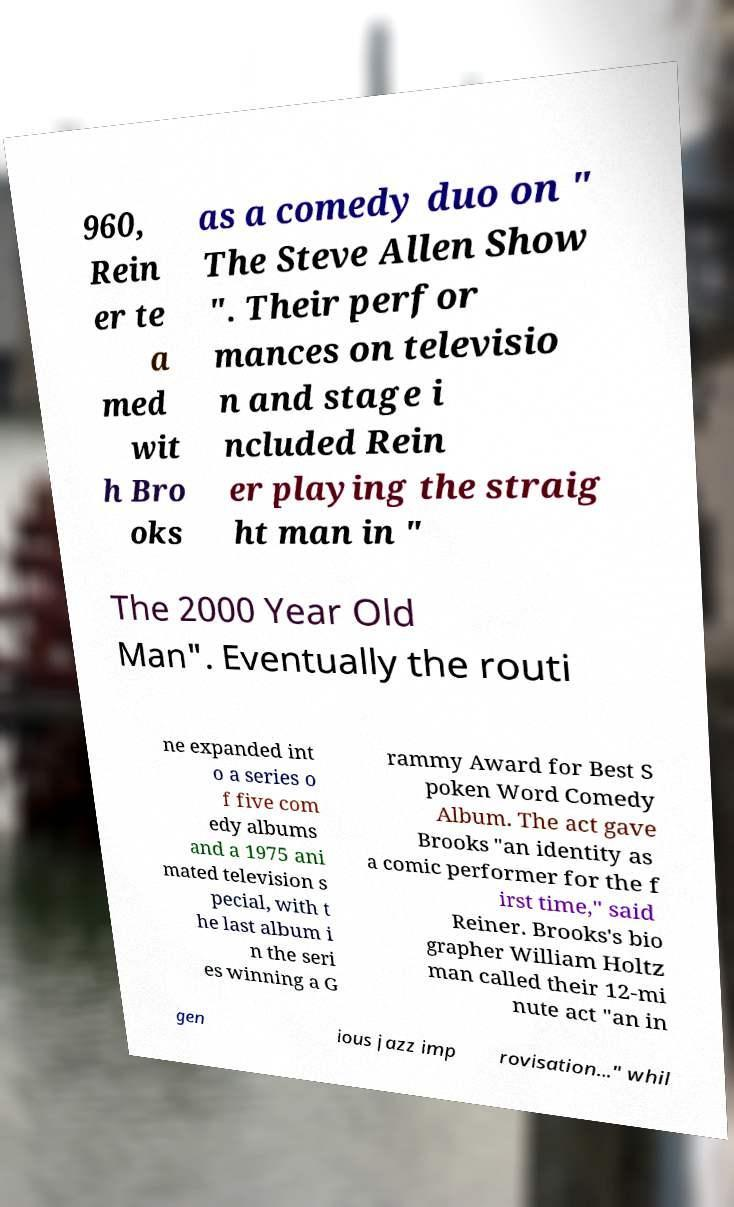Can you read and provide the text displayed in the image?This photo seems to have some interesting text. Can you extract and type it out for me? 960, Rein er te a med wit h Bro oks as a comedy duo on " The Steve Allen Show ". Their perfor mances on televisio n and stage i ncluded Rein er playing the straig ht man in " The 2000 Year Old Man". Eventually the routi ne expanded int o a series o f five com edy albums and a 1975 ani mated television s pecial, with t he last album i n the seri es winning a G rammy Award for Best S poken Word Comedy Album. The act gave Brooks "an identity as a comic performer for the f irst time," said Reiner. Brooks's bio grapher William Holtz man called their 12-mi nute act "an in gen ious jazz imp rovisation..." whil 